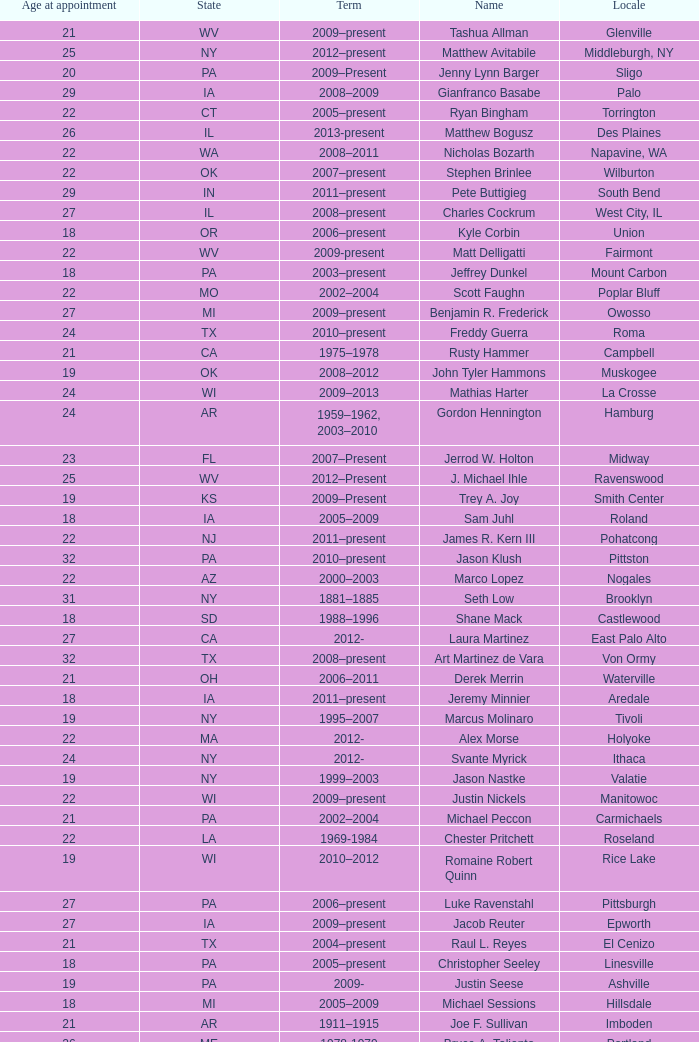What is the name of the holland locale Philip A. Tanis. 